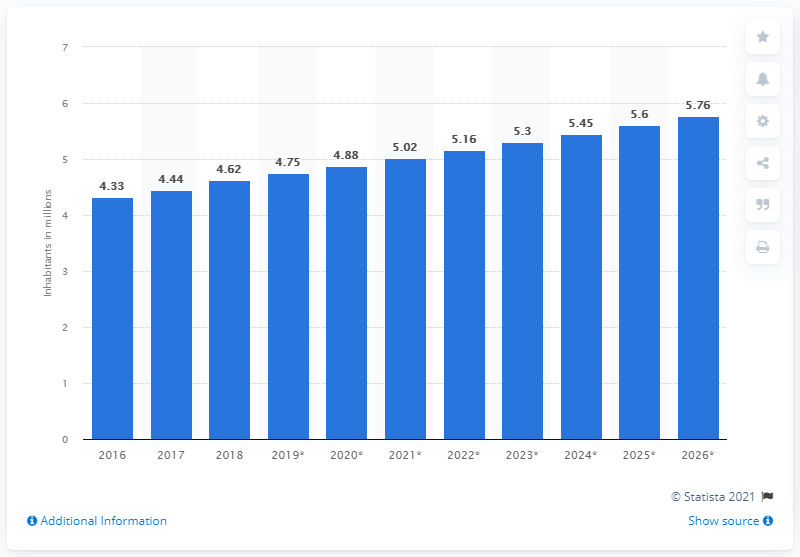What was Kuwait's population in 2018? According to the displayed bar chart, Kuwait's population in 2018 was approximately 4.62 million inhabitants. This information reflects a specific point in time and population figures are subject to change due to various factors such as birth rates, death rates, and migration. 